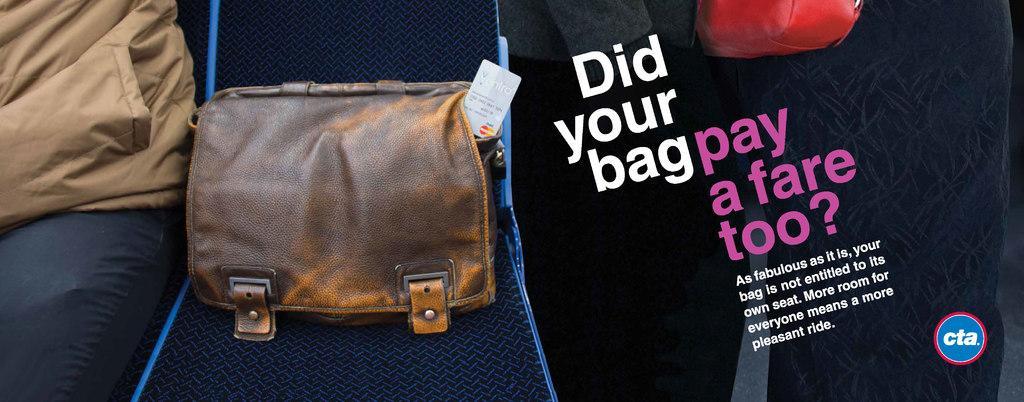How would you summarize this image in a sentence or two? In this picture a lady is sitting to the left side of the image and beside he there is a brown bag on the seat which has master card tag on it. To the right side of the image there is a quote named did your bag pay a fare to? , As fabulous as it is , your bag is not entitled to tits own seat. More room for everyone means a more pleasant ride. 